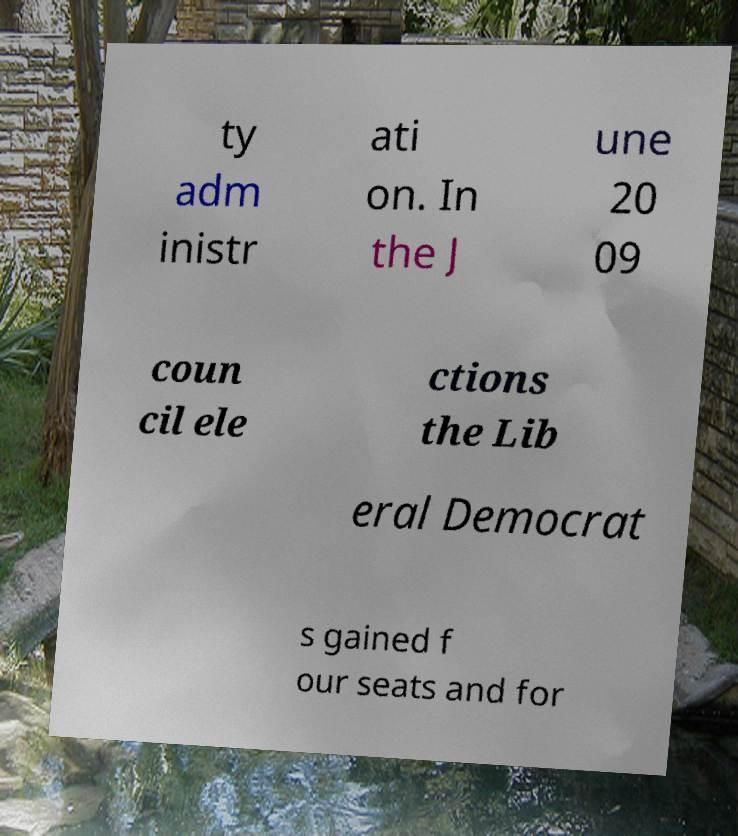Please identify and transcribe the text found in this image. ty adm inistr ati on. In the J une 20 09 coun cil ele ctions the Lib eral Democrat s gained f our seats and for 